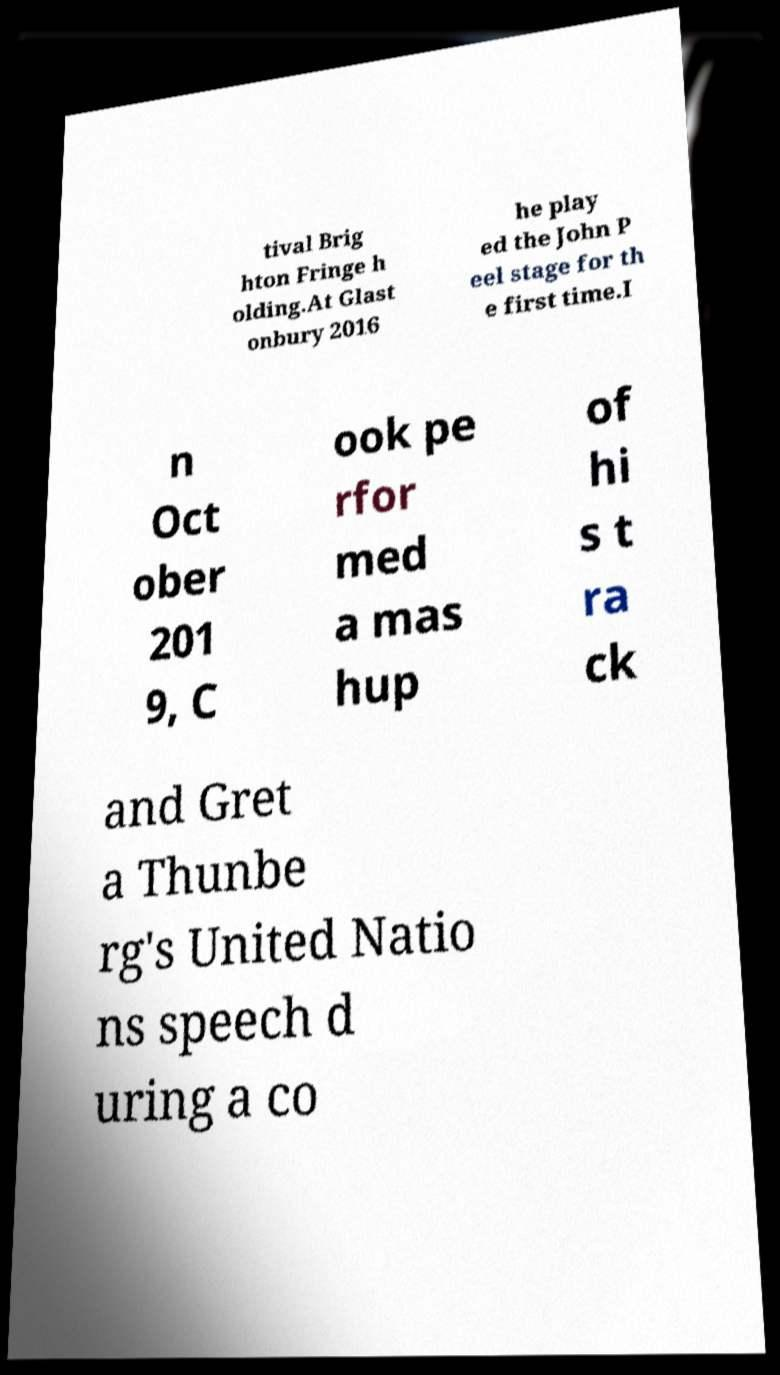Could you assist in decoding the text presented in this image and type it out clearly? tival Brig hton Fringe h olding.At Glast onbury 2016 he play ed the John P eel stage for th e first time.I n Oct ober 201 9, C ook pe rfor med a mas hup of hi s t ra ck and Gret a Thunbe rg's United Natio ns speech d uring a co 